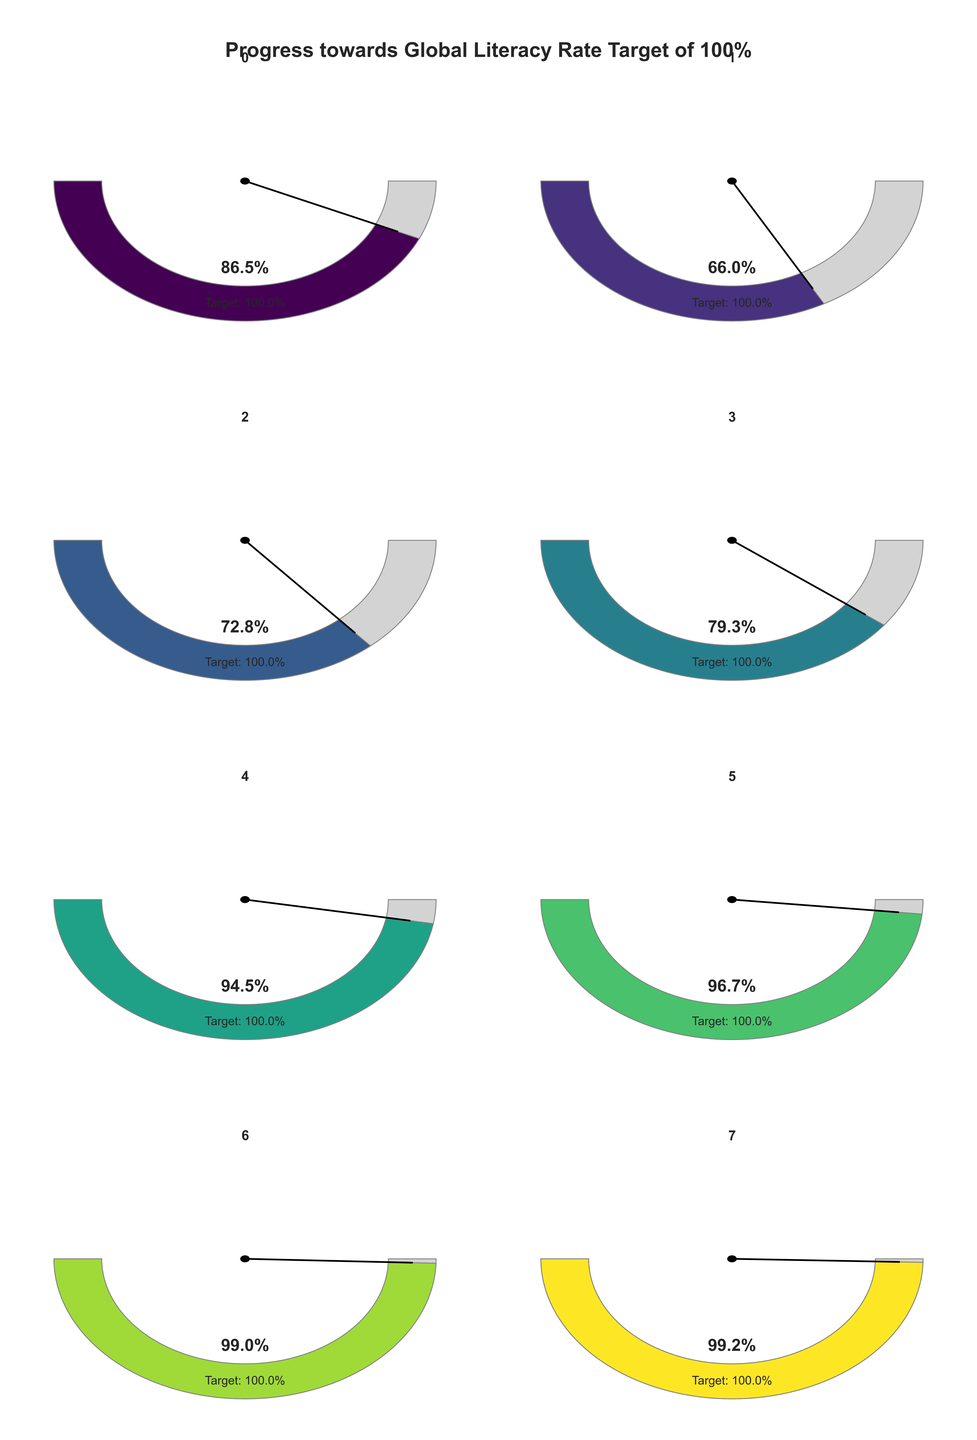What is the title of the figure? The title is displayed prominently at the top of the figure.
Answer: Progress towards Global Literacy Rate Target of 100% Which region has the highest literacy rate according to the figure? The gauge for Europe & Central Asia shows the highest literacy rate when compared visually with other regions.
Answer: Europe & Central Asia What is the current literacy rate in Sub-Saharan Africa? The value is shown inside the gauge for Sub-Saharan Africa.
Answer: 66.0% How much does South Asia need to improve to reach the 100% target? Subtract South Asia's current literacy rate from the target: 100% - 72.8% = 27.2%.
Answer: 27.2% Which regions have a literacy rate above 95%? By checking the gauges, East Asia & Pacific, North America, and Europe & Central Asia all show literacy rates above 95%.
Answer: East Asia & Pacific, North America, Europe & Central Asia What is the average literacy rate for the regions shown in the figure? Add up all the literacy rates and divide by the number of regions: (86.5 + 66.0 + 72.8 + 79.3 + 94.5 + 96.7 + 99.0 + 99.2) / 8 = 86.75%.
Answer: 86.75% Which region is closest to achieving the 100% literacy target? North America's gauge shows the smallest difference from the 100% target.
Answer: North America Compare the literacy rates of Latin America & Caribbean and Middle East & North Africa. Which is higher? The gauge for Latin America & Caribbean shows a higher literacy rate than Middle East & North Africa.
Answer: Latin America & Caribbean How many regions have a literacy rate below 80%? By counting the gauges with values below 80%, we find Sub-Saharan Africa and South Asia.
Answer: 2 What is the difference in literacy rate between East Asia & Pacific and Sub-Saharan Africa? Subtract Sub-Saharan Africa's rate from East Asia & Pacific's: 96.7% - 66.0% = 30.7%.
Answer: 30.7% 